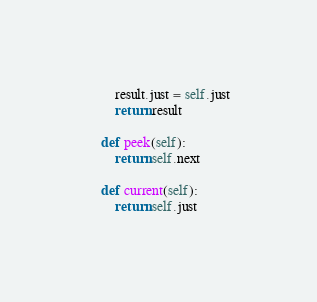Convert code to text. <code><loc_0><loc_0><loc_500><loc_500><_Python_>        result.just = self.just
        return result

    def peek(self):
        return self.next
    
    def current(self):
        return self.just
</code> 